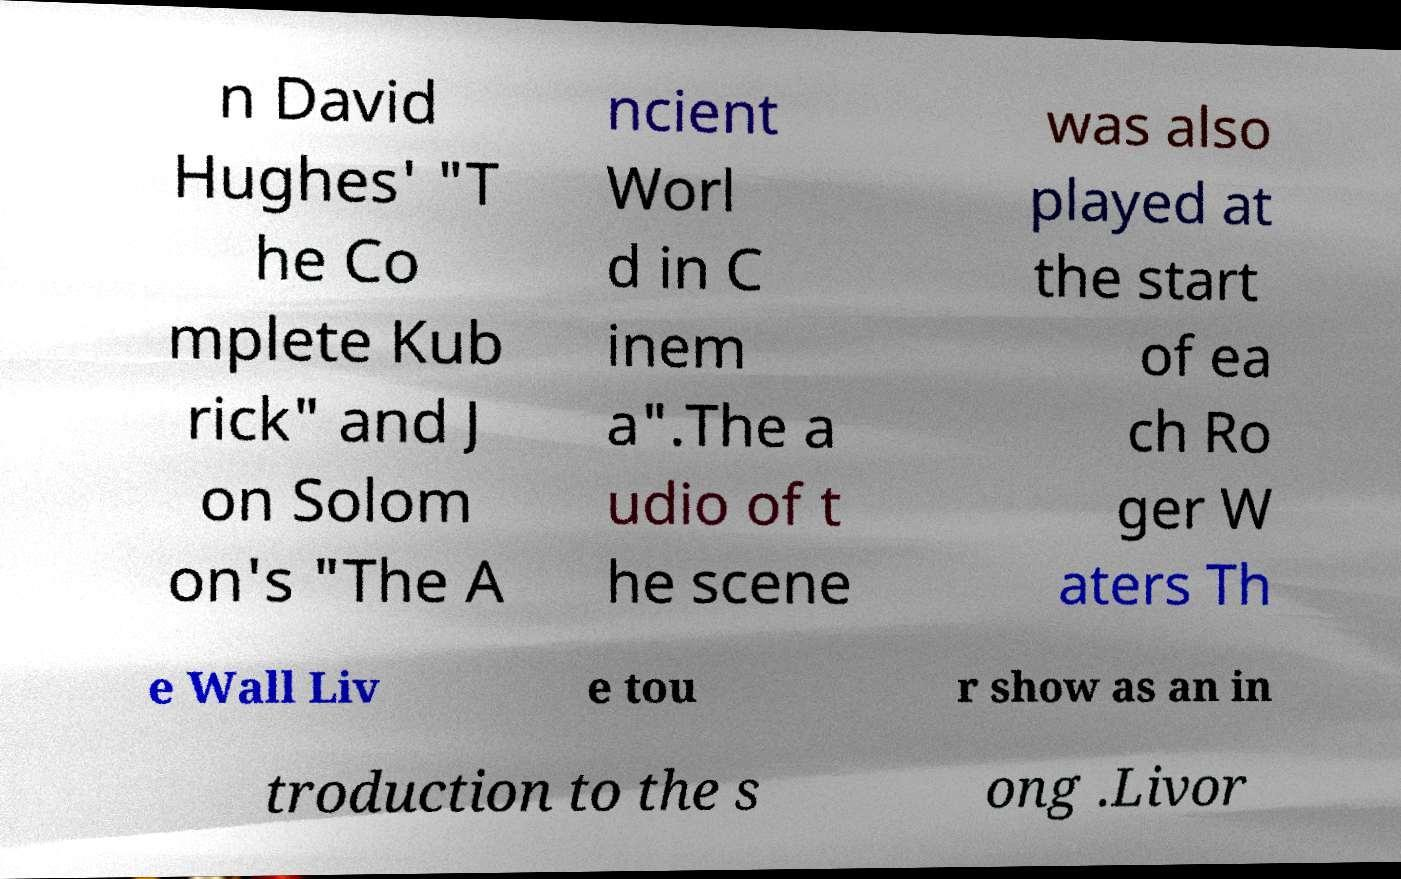What messages or text are displayed in this image? I need them in a readable, typed format. n David Hughes' "T he Co mplete Kub rick" and J on Solom on's "The A ncient Worl d in C inem a".The a udio of t he scene was also played at the start of ea ch Ro ger W aters Th e Wall Liv e tou r show as an in troduction to the s ong .Livor 